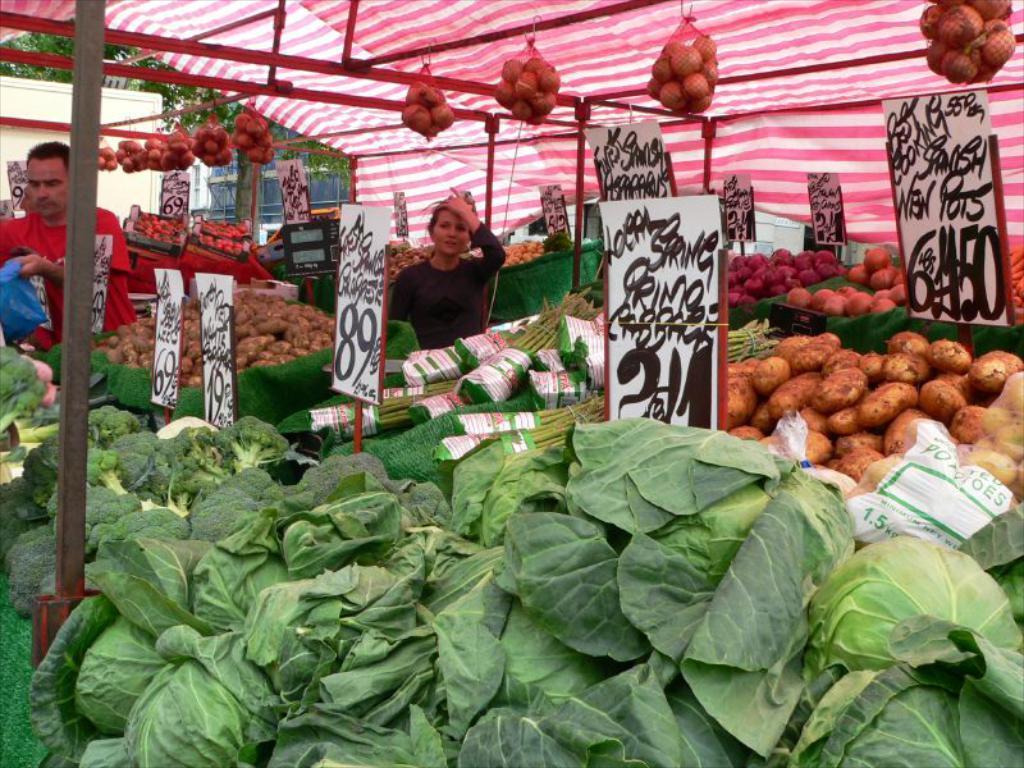Please provide a concise description of this image. In this image there are fruits and vegetables on the tables. There are boards with text and numbers near the tables. There are two people standing at the tables. At the top there is a tent. In the background there are buildings and trees. 